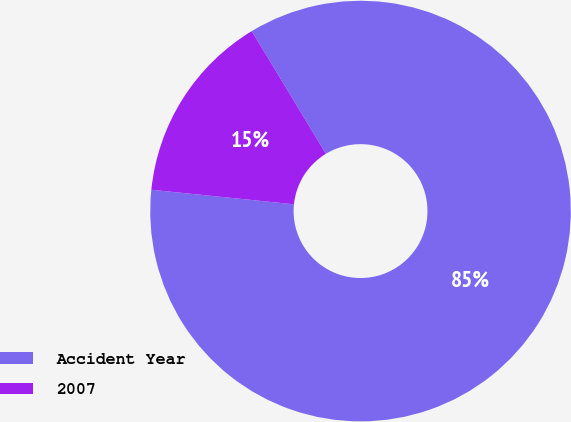Convert chart to OTSL. <chart><loc_0><loc_0><loc_500><loc_500><pie_chart><fcel>Accident Year<fcel>2007<nl><fcel>85.27%<fcel>14.73%<nl></chart> 